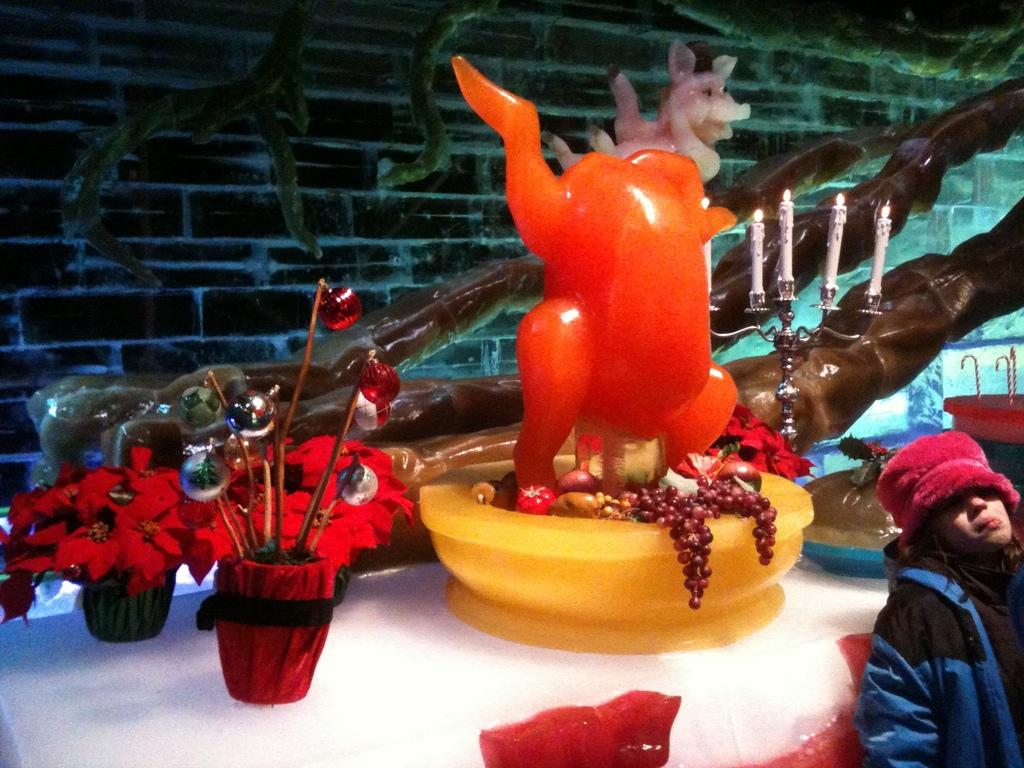What objects are present in the image that are used for growing plants? There are flower pots in the image. What type of objects can be seen on the table in the image? There are toys on the table in the image. Where is the girl located in the image? The girl is in the bottom right side of the image. How many beds are visible in the image? There are no beds present in the image. What type of board is being used by the girl in the image? There is no board present in the image, and the girl is not shown using any board. 